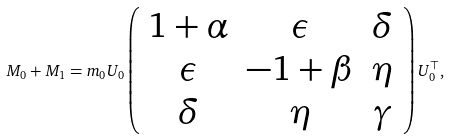Convert formula to latex. <formula><loc_0><loc_0><loc_500><loc_500>M _ { 0 } + M _ { 1 } = m _ { 0 } U _ { 0 } \left ( \begin{array} { c c c } 1 + \alpha & \epsilon & \delta \\ \epsilon & - 1 + \beta & \eta \\ \delta & \eta & \gamma \end{array} \right ) U _ { 0 } ^ { \top } ,</formula> 